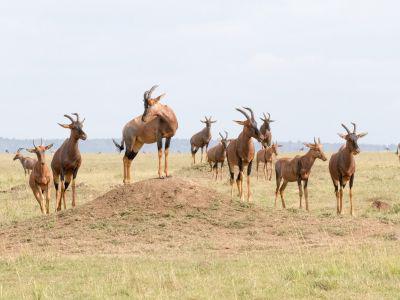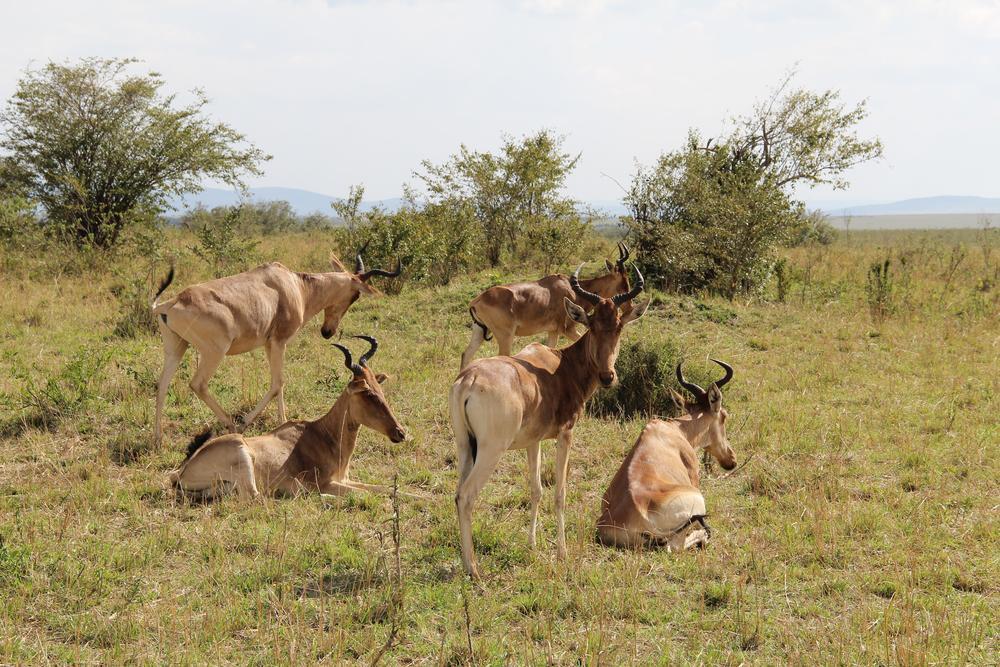The first image is the image on the left, the second image is the image on the right. Assess this claim about the two images: "There are five animals in the image on the right.". Correct or not? Answer yes or no. Yes. 